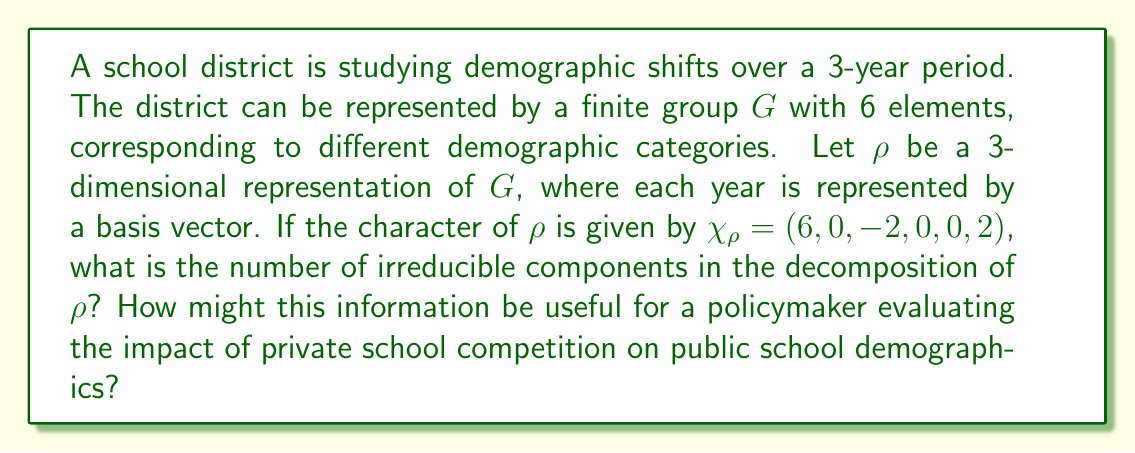What is the answer to this math problem? To solve this problem, we'll follow these steps:

1) Recall that the number of irreducible components in a representation is equal to the inner product of its character with itself.

2) For a finite group $G$, the inner product of two characters $\chi$ and $\psi$ is defined as:

   $\langle \chi, \psi \rangle = \frac{1}{|G|} \sum_{g \in G} \chi(g) \overline{\psi(g)}$

3) In our case, we're calculating $\langle \chi_\rho, \chi_\rho \rangle$, so $\chi = \psi = \chi_\rho$

4) We're given that $\chi_\rho = (6, 0, -2, 0, 0, 2)$ and $|G| = 6$

5) Calculating the inner product:

   $\langle \chi_\rho, \chi_\rho \rangle = \frac{1}{6} (6^2 + 0^2 + (-2)^2 + 0^2 + 0^2 + 2^2)$

6) Simplifying:

   $\langle \chi_\rho, \chi_\rho \rangle = \frac{1}{6} (36 + 0 + 4 + 0 + 0 + 4) = \frac{44}{6} = \frac{22}{3}$

7) Therefore, the number of irreducible components is $\frac{22}{3}$.

For a policymaker, this result indicates the complexity of demographic shifts in the district. A higher number of irreducible components suggests more intricate patterns of change, which could be influenced by factors like private school competition. This information could be used to:

a) Assess the diversity of demographic changes in the district.
b) Evaluate the potential impact of private schools on public school demographics.
c) Inform policies to maintain or improve demographic balance in public schools.
d) Guide resource allocation to address specific demographic shifts.
Answer: $\frac{22}{3}$ 